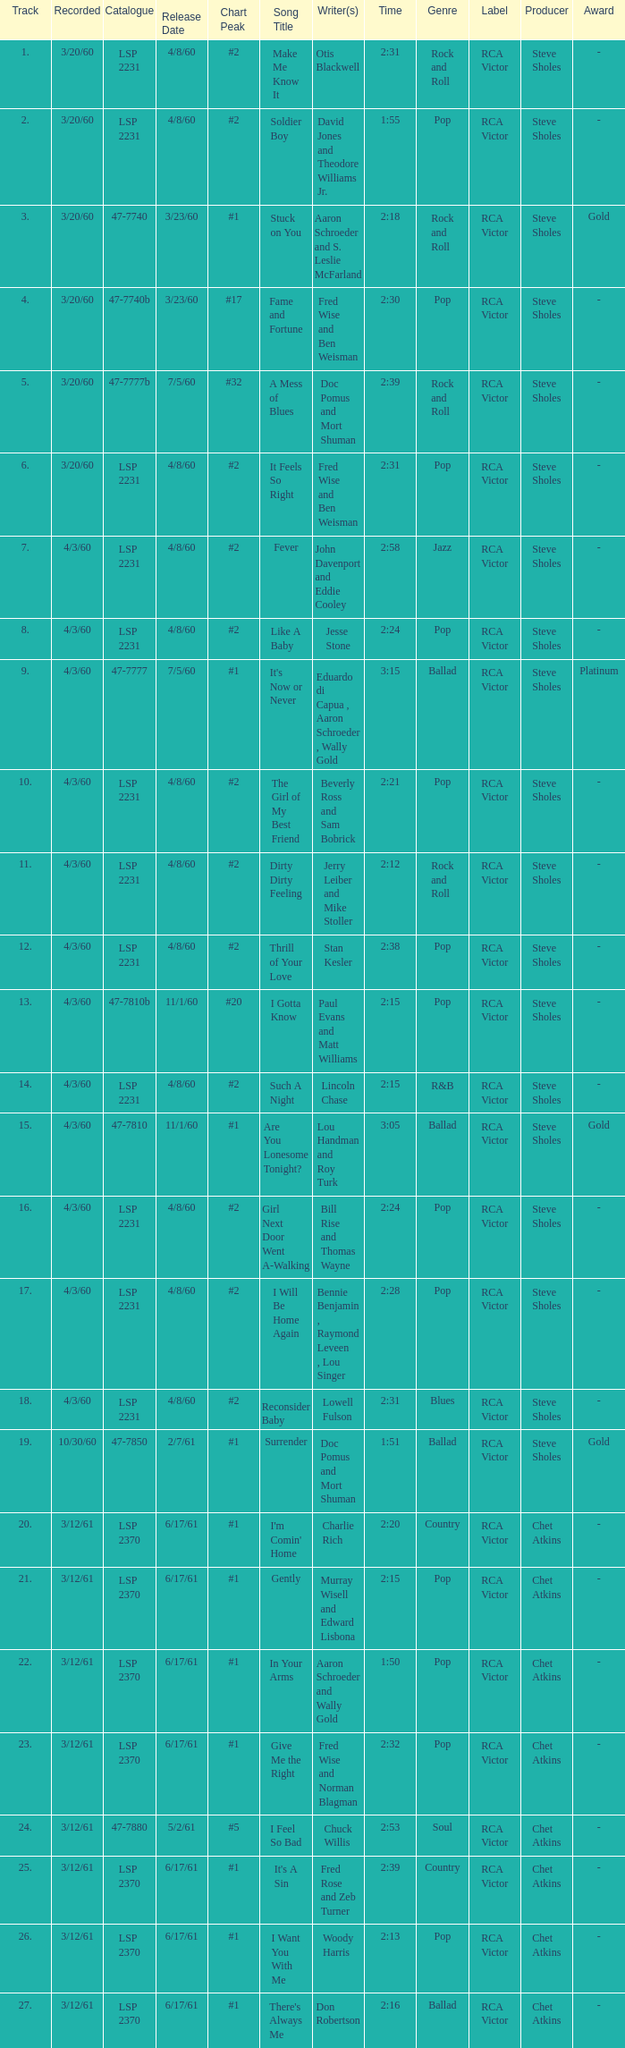What catalogue is the song It's Now or Never? 47-7777. 